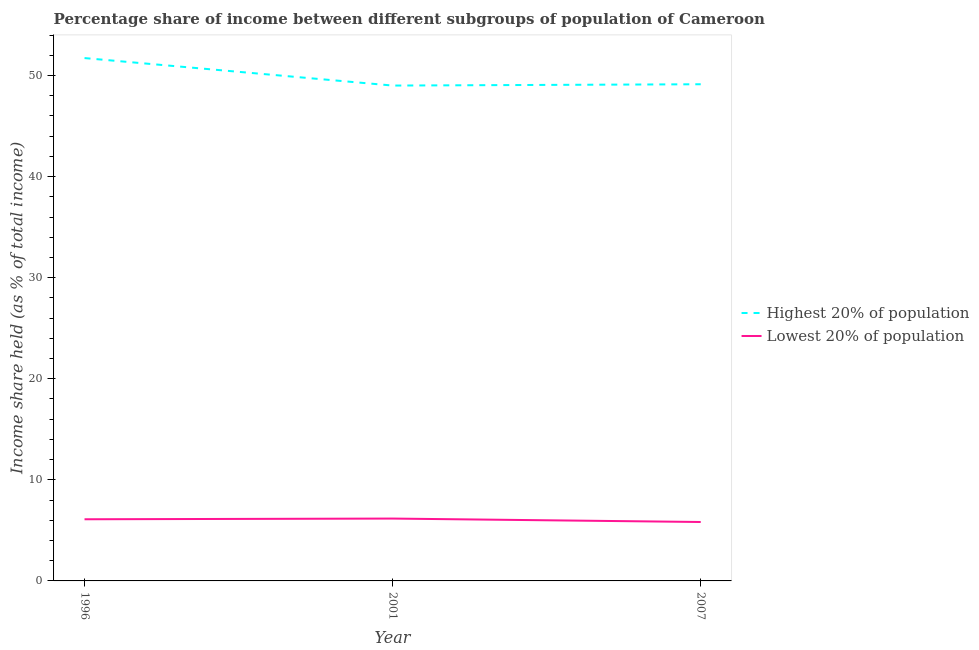Is the number of lines equal to the number of legend labels?
Your response must be concise. Yes. What is the income share held by highest 20% of the population in 2007?
Offer a terse response. 49.14. Across all years, what is the maximum income share held by highest 20% of the population?
Ensure brevity in your answer.  51.73. Across all years, what is the minimum income share held by lowest 20% of the population?
Your answer should be very brief. 5.83. In which year was the income share held by lowest 20% of the population maximum?
Your response must be concise. 2001. In which year was the income share held by highest 20% of the population minimum?
Provide a short and direct response. 2001. What is the total income share held by lowest 20% of the population in the graph?
Provide a succinct answer. 18.1. What is the difference between the income share held by highest 20% of the population in 1996 and that in 2007?
Ensure brevity in your answer.  2.59. What is the difference between the income share held by lowest 20% of the population in 2001 and the income share held by highest 20% of the population in 2007?
Ensure brevity in your answer.  -42.97. What is the average income share held by highest 20% of the population per year?
Your answer should be very brief. 49.96. In the year 2007, what is the difference between the income share held by highest 20% of the population and income share held by lowest 20% of the population?
Provide a succinct answer. 43.31. What is the ratio of the income share held by highest 20% of the population in 1996 to that in 2007?
Your answer should be very brief. 1.05. Is the difference between the income share held by lowest 20% of the population in 1996 and 2007 greater than the difference between the income share held by highest 20% of the population in 1996 and 2007?
Your answer should be very brief. No. What is the difference between the highest and the second highest income share held by highest 20% of the population?
Provide a succinct answer. 2.59. What is the difference between the highest and the lowest income share held by highest 20% of the population?
Offer a very short reply. 2.72. Does the income share held by lowest 20% of the population monotonically increase over the years?
Give a very brief answer. No. Is the income share held by highest 20% of the population strictly less than the income share held by lowest 20% of the population over the years?
Give a very brief answer. No. How many lines are there?
Make the answer very short. 2. Are the values on the major ticks of Y-axis written in scientific E-notation?
Offer a terse response. No. Does the graph contain grids?
Keep it short and to the point. No. How are the legend labels stacked?
Your response must be concise. Vertical. What is the title of the graph?
Your answer should be compact. Percentage share of income between different subgroups of population of Cameroon. What is the label or title of the X-axis?
Your response must be concise. Year. What is the label or title of the Y-axis?
Your response must be concise. Income share held (as % of total income). What is the Income share held (as % of total income) of Highest 20% of population in 1996?
Give a very brief answer. 51.73. What is the Income share held (as % of total income) of Lowest 20% of population in 1996?
Make the answer very short. 6.1. What is the Income share held (as % of total income) in Highest 20% of population in 2001?
Ensure brevity in your answer.  49.01. What is the Income share held (as % of total income) of Lowest 20% of population in 2001?
Your answer should be very brief. 6.17. What is the Income share held (as % of total income) in Highest 20% of population in 2007?
Your answer should be very brief. 49.14. What is the Income share held (as % of total income) of Lowest 20% of population in 2007?
Provide a succinct answer. 5.83. Across all years, what is the maximum Income share held (as % of total income) in Highest 20% of population?
Provide a succinct answer. 51.73. Across all years, what is the maximum Income share held (as % of total income) in Lowest 20% of population?
Give a very brief answer. 6.17. Across all years, what is the minimum Income share held (as % of total income) in Highest 20% of population?
Your answer should be very brief. 49.01. Across all years, what is the minimum Income share held (as % of total income) of Lowest 20% of population?
Keep it short and to the point. 5.83. What is the total Income share held (as % of total income) in Highest 20% of population in the graph?
Make the answer very short. 149.88. What is the difference between the Income share held (as % of total income) in Highest 20% of population in 1996 and that in 2001?
Give a very brief answer. 2.72. What is the difference between the Income share held (as % of total income) in Lowest 20% of population in 1996 and that in 2001?
Your answer should be very brief. -0.07. What is the difference between the Income share held (as % of total income) in Highest 20% of population in 1996 and that in 2007?
Your answer should be compact. 2.59. What is the difference between the Income share held (as % of total income) of Lowest 20% of population in 1996 and that in 2007?
Provide a short and direct response. 0.27. What is the difference between the Income share held (as % of total income) in Highest 20% of population in 2001 and that in 2007?
Provide a succinct answer. -0.13. What is the difference between the Income share held (as % of total income) in Lowest 20% of population in 2001 and that in 2007?
Your answer should be very brief. 0.34. What is the difference between the Income share held (as % of total income) in Highest 20% of population in 1996 and the Income share held (as % of total income) in Lowest 20% of population in 2001?
Your answer should be very brief. 45.56. What is the difference between the Income share held (as % of total income) of Highest 20% of population in 1996 and the Income share held (as % of total income) of Lowest 20% of population in 2007?
Your answer should be very brief. 45.9. What is the difference between the Income share held (as % of total income) of Highest 20% of population in 2001 and the Income share held (as % of total income) of Lowest 20% of population in 2007?
Make the answer very short. 43.18. What is the average Income share held (as % of total income) in Highest 20% of population per year?
Your answer should be very brief. 49.96. What is the average Income share held (as % of total income) of Lowest 20% of population per year?
Make the answer very short. 6.03. In the year 1996, what is the difference between the Income share held (as % of total income) in Highest 20% of population and Income share held (as % of total income) in Lowest 20% of population?
Give a very brief answer. 45.63. In the year 2001, what is the difference between the Income share held (as % of total income) in Highest 20% of population and Income share held (as % of total income) in Lowest 20% of population?
Make the answer very short. 42.84. In the year 2007, what is the difference between the Income share held (as % of total income) in Highest 20% of population and Income share held (as % of total income) in Lowest 20% of population?
Ensure brevity in your answer.  43.31. What is the ratio of the Income share held (as % of total income) of Highest 20% of population in 1996 to that in 2001?
Your answer should be very brief. 1.06. What is the ratio of the Income share held (as % of total income) of Lowest 20% of population in 1996 to that in 2001?
Your answer should be very brief. 0.99. What is the ratio of the Income share held (as % of total income) in Highest 20% of population in 1996 to that in 2007?
Give a very brief answer. 1.05. What is the ratio of the Income share held (as % of total income) of Lowest 20% of population in 1996 to that in 2007?
Offer a terse response. 1.05. What is the ratio of the Income share held (as % of total income) in Lowest 20% of population in 2001 to that in 2007?
Provide a succinct answer. 1.06. What is the difference between the highest and the second highest Income share held (as % of total income) of Highest 20% of population?
Your answer should be compact. 2.59. What is the difference between the highest and the second highest Income share held (as % of total income) of Lowest 20% of population?
Provide a succinct answer. 0.07. What is the difference between the highest and the lowest Income share held (as % of total income) of Highest 20% of population?
Give a very brief answer. 2.72. What is the difference between the highest and the lowest Income share held (as % of total income) of Lowest 20% of population?
Provide a succinct answer. 0.34. 